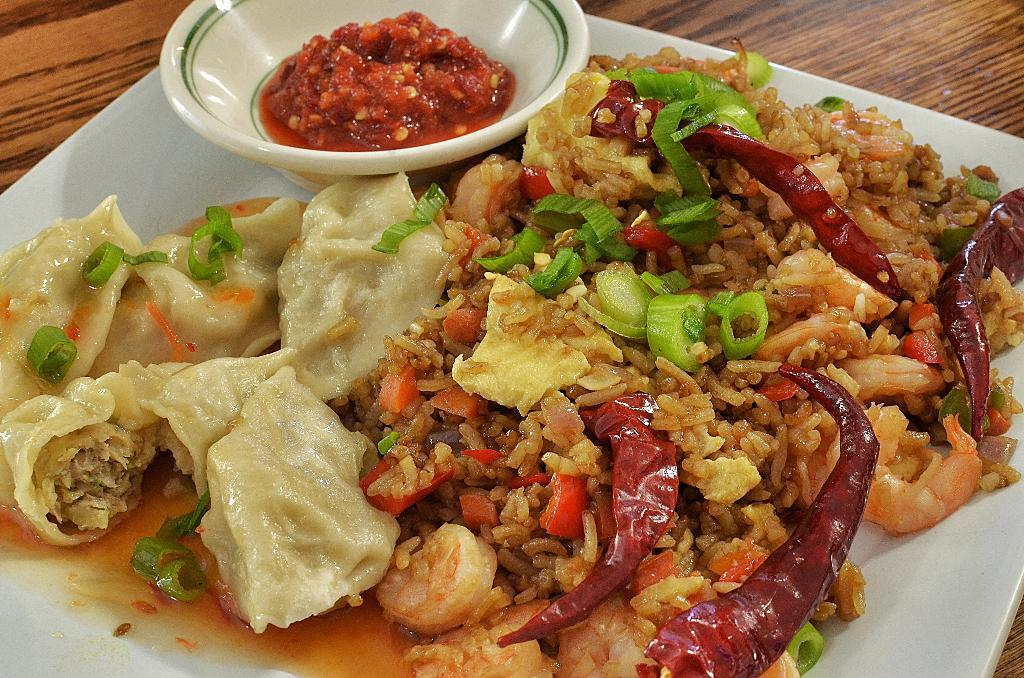What is on the wooden table in the image? There is a white plate on a wooden table in the image. What is on the white plate? There is a food item on the plate. What else is on the plate? There is a bowl with a food item on the plate. What type of food can be seen in the bowl? The food item in the bowl contains prawns. What other ingredients are present in the food item on the plate? The food item on the plate contains chilies and other unspecified items. What type of cake is being sung about in the image? There is no cake or singing present in the image; it features a white plate with food items on a wooden table. How long does it take for the minute to pass in the image? The concept of time passing is not depicted in the image, so it cannot be determined from the image. 